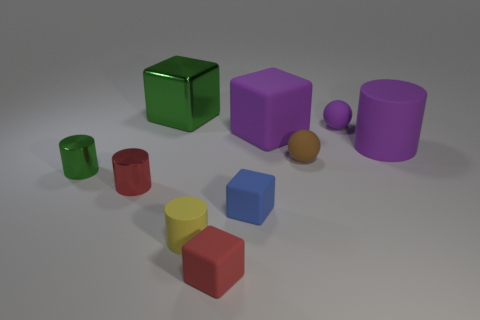What size is the purple thing that is the same shape as the large green object?
Make the answer very short. Large. Are there the same number of green blocks in front of the red matte thing and blue matte cubes behind the purple block?
Provide a short and direct response. Yes. What number of other objects are there of the same material as the blue object?
Ensure brevity in your answer.  6. Is the number of purple rubber spheres that are to the right of the small purple thing the same as the number of yellow matte things?
Make the answer very short. No. Does the yellow cylinder have the same size as the cylinder that is behind the tiny green thing?
Your response must be concise. No. There is a small red thing on the right side of the green metallic block; what is its shape?
Provide a short and direct response. Cube. Is there any other thing that has the same shape as the big green metal object?
Make the answer very short. Yes. Is there a brown matte object?
Give a very brief answer. Yes. Does the block behind the big rubber cube have the same size as the purple matte object left of the tiny brown ball?
Provide a succinct answer. Yes. What is the material of the large object that is right of the blue matte thing and left of the big purple rubber cylinder?
Your response must be concise. Rubber. 